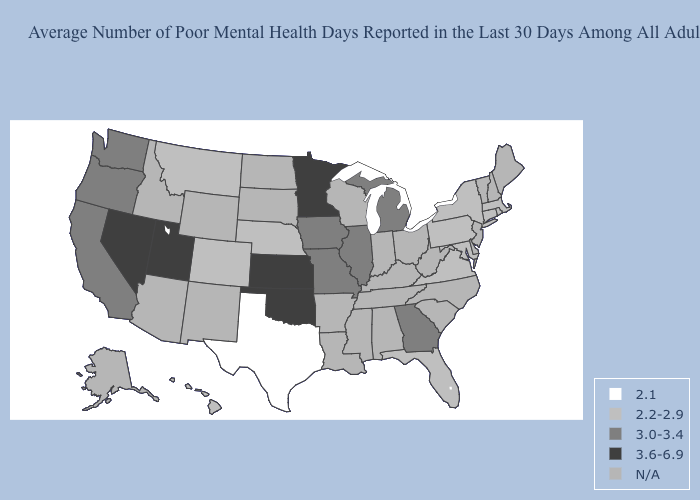Name the states that have a value in the range 3.6-6.9?
Answer briefly. Kansas, Minnesota, Nevada, Oklahoma, Utah. Does Montana have the lowest value in the West?
Quick response, please. Yes. Name the states that have a value in the range 3.0-3.4?
Short answer required. California, Georgia, Illinois, Iowa, Michigan, Missouri, Oregon, Washington. Name the states that have a value in the range 3.0-3.4?
Concise answer only. California, Georgia, Illinois, Iowa, Michigan, Missouri, Oregon, Washington. What is the value of Colorado?
Answer briefly. 2.2-2.9. What is the highest value in states that border Oregon?
Give a very brief answer. 3.6-6.9. What is the value of Nevada?
Answer briefly. 3.6-6.9. Among the states that border Nevada , does Utah have the lowest value?
Concise answer only. No. What is the value of Minnesota?
Be succinct. 3.6-6.9. Which states have the highest value in the USA?
Concise answer only. Kansas, Minnesota, Nevada, Oklahoma, Utah. Which states hav the highest value in the West?
Answer briefly. Nevada, Utah. Name the states that have a value in the range 2.2-2.9?
Keep it brief. Colorado, Connecticut, Florida, Hawaii, Maryland, Massachusetts, Montana, Nebraska, New York, Pennsylvania, Rhode Island, Virginia. What is the value of Wisconsin?
Quick response, please. N/A. What is the value of Iowa?
Be succinct. 3.0-3.4. 